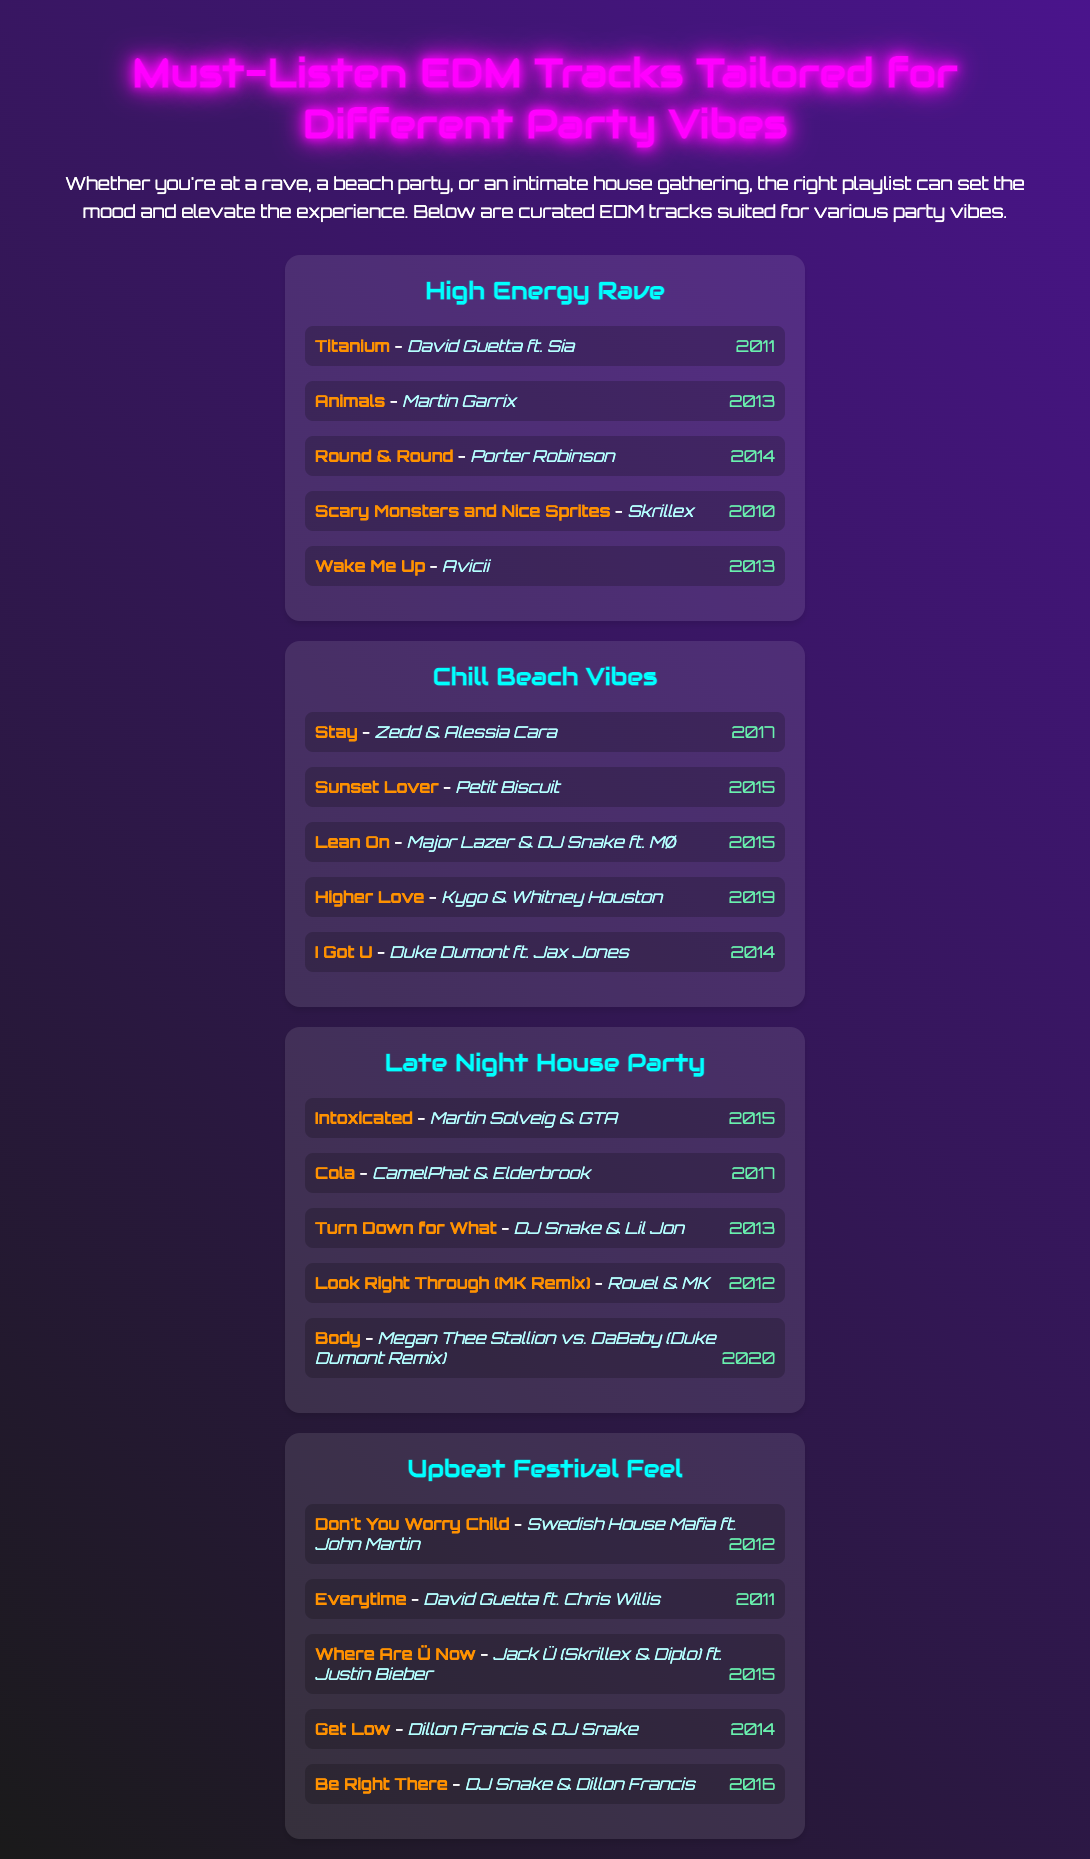What is the title of the menu? The title of the menu is presented at the top of the document, stating the curated content.
Answer: Must-Listen EDM Tracks Tailored for Different Party Vibes How many playlists are in the menu? The number of playlists can be counted from the document, which lists each one.
Answer: Four Who is the artist of "Titanium"? The document lists the artist associated with the track "Titanium" under the High Energy Rave playlist.
Answer: David Guetta ft. Sia Which year was "Lean On" released? The year of release is shown next to the track name in the Chill Beach Vibes playlist.
Answer: 2015 What vibe is the "Upbeat Festival Feel" playlist tailored for? The playlist title indicates the type of event it is designed for.
Answer: Festival Which track features "Avicii"? The document specifies the artist associated with the track "Wake Me Up" in the High Energy Rave playlist.
Answer: Wake Me Up How many tracks are listed in the "Chill Beach Vibes" playlist? The total number of tracks can be counted based on the entries under the specific playlist in the document.
Answer: Five What is the theme of the "Late Night House Party" playlist? The title of the playlist conveys its intended atmosphere or event type.
Answer: House Party What color is used for the playlist titles in the document? The color used for playlist titles can be identified through visual formatting explained in the document.
Answer: Cyan 